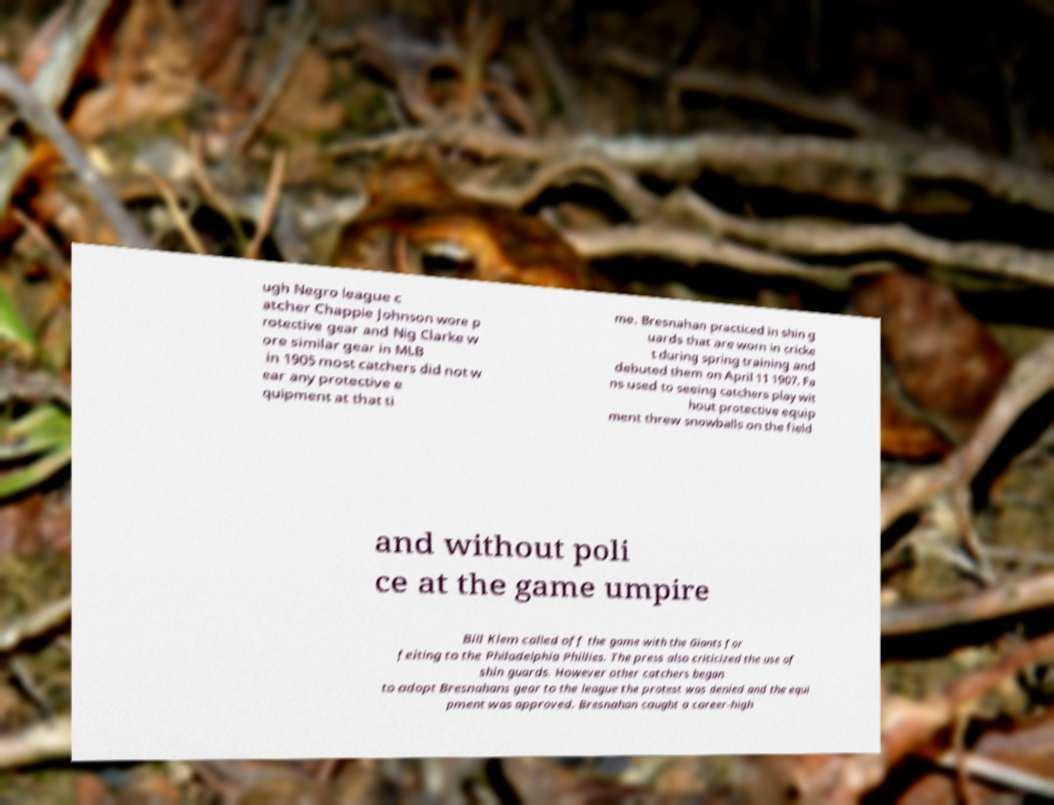Could you extract and type out the text from this image? ugh Negro league c atcher Chappie Johnson wore p rotective gear and Nig Clarke w ore similar gear in MLB in 1905 most catchers did not w ear any protective e quipment at that ti me. Bresnahan practiced in shin g uards that are worn in cricke t during spring training and debuted them on April 11 1907. Fa ns used to seeing catchers play wit hout protective equip ment threw snowballs on the field and without poli ce at the game umpire Bill Klem called off the game with the Giants for feiting to the Philadelphia Phillies. The press also criticized the use of shin guards. However other catchers began to adopt Bresnahans gear to the league the protest was denied and the equi pment was approved. Bresnahan caught a career-high 